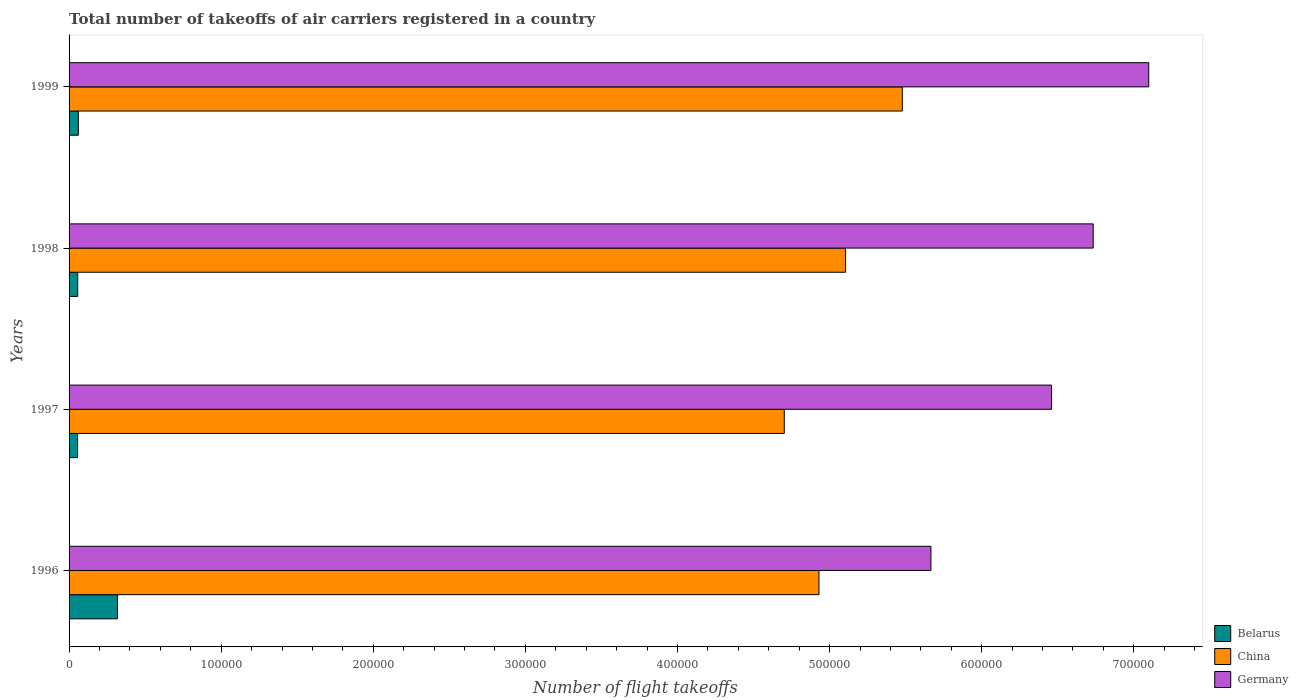Are the number of bars on each tick of the Y-axis equal?
Offer a terse response. Yes. How many bars are there on the 2nd tick from the top?
Ensure brevity in your answer.  3. What is the total number of flight takeoffs in Germany in 1999?
Ensure brevity in your answer.  7.10e+05. Across all years, what is the maximum total number of flight takeoffs in China?
Provide a succinct answer. 5.48e+05. Across all years, what is the minimum total number of flight takeoffs in China?
Provide a short and direct response. 4.70e+05. In which year was the total number of flight takeoffs in Belarus maximum?
Provide a succinct answer. 1996. What is the total total number of flight takeoffs in China in the graph?
Make the answer very short. 2.02e+06. What is the difference between the total number of flight takeoffs in Germany in 1997 and that in 1998?
Give a very brief answer. -2.74e+04. What is the difference between the total number of flight takeoffs in China in 1996 and the total number of flight takeoffs in Belarus in 1998?
Provide a short and direct response. 4.87e+05. What is the average total number of flight takeoffs in Belarus per year?
Ensure brevity in your answer.  1.23e+04. In the year 1998, what is the difference between the total number of flight takeoffs in China and total number of flight takeoffs in Germany?
Keep it short and to the point. -1.63e+05. In how many years, is the total number of flight takeoffs in Belarus greater than 680000 ?
Offer a terse response. 0. What is the ratio of the total number of flight takeoffs in Germany in 1996 to that in 1997?
Offer a terse response. 0.88. Is the total number of flight takeoffs in China in 1997 less than that in 1999?
Keep it short and to the point. Yes. Is the difference between the total number of flight takeoffs in China in 1996 and 1997 greater than the difference between the total number of flight takeoffs in Germany in 1996 and 1997?
Give a very brief answer. Yes. What is the difference between the highest and the second highest total number of flight takeoffs in Belarus?
Make the answer very short. 2.57e+04. What is the difference between the highest and the lowest total number of flight takeoffs in Germany?
Your answer should be very brief. 1.43e+05. Is the sum of the total number of flight takeoffs in Germany in 1996 and 1998 greater than the maximum total number of flight takeoffs in China across all years?
Provide a short and direct response. Yes. What does the 3rd bar from the top in 1998 represents?
Ensure brevity in your answer.  Belarus. What does the 2nd bar from the bottom in 1998 represents?
Ensure brevity in your answer.  China. Is it the case that in every year, the sum of the total number of flight takeoffs in Germany and total number of flight takeoffs in China is greater than the total number of flight takeoffs in Belarus?
Offer a terse response. Yes. How many bars are there?
Your answer should be very brief. 12. Are all the bars in the graph horizontal?
Offer a very short reply. Yes. Does the graph contain any zero values?
Make the answer very short. No. Does the graph contain grids?
Your answer should be compact. No. Where does the legend appear in the graph?
Provide a short and direct response. Bottom right. How are the legend labels stacked?
Give a very brief answer. Vertical. What is the title of the graph?
Your answer should be very brief. Total number of takeoffs of air carriers registered in a country. What is the label or title of the X-axis?
Provide a succinct answer. Number of flight takeoffs. What is the Number of flight takeoffs in Belarus in 1996?
Ensure brevity in your answer.  3.18e+04. What is the Number of flight takeoffs in China in 1996?
Your answer should be very brief. 4.93e+05. What is the Number of flight takeoffs in Germany in 1996?
Your response must be concise. 5.67e+05. What is the Number of flight takeoffs of Belarus in 1997?
Your answer should be compact. 5600. What is the Number of flight takeoffs of China in 1997?
Make the answer very short. 4.70e+05. What is the Number of flight takeoffs in Germany in 1997?
Provide a short and direct response. 6.46e+05. What is the Number of flight takeoffs of Belarus in 1998?
Offer a terse response. 5700. What is the Number of flight takeoffs in China in 1998?
Give a very brief answer. 5.10e+05. What is the Number of flight takeoffs of Germany in 1998?
Your answer should be compact. 6.73e+05. What is the Number of flight takeoffs of Belarus in 1999?
Offer a terse response. 6100. What is the Number of flight takeoffs of China in 1999?
Offer a very short reply. 5.48e+05. What is the Number of flight takeoffs of Germany in 1999?
Give a very brief answer. 7.10e+05. Across all years, what is the maximum Number of flight takeoffs in Belarus?
Your answer should be compact. 3.18e+04. Across all years, what is the maximum Number of flight takeoffs of China?
Your answer should be very brief. 5.48e+05. Across all years, what is the maximum Number of flight takeoffs of Germany?
Provide a short and direct response. 7.10e+05. Across all years, what is the minimum Number of flight takeoffs in Belarus?
Provide a succinct answer. 5600. Across all years, what is the minimum Number of flight takeoffs of China?
Your response must be concise. 4.70e+05. Across all years, what is the minimum Number of flight takeoffs in Germany?
Give a very brief answer. 5.67e+05. What is the total Number of flight takeoffs of Belarus in the graph?
Offer a terse response. 4.92e+04. What is the total Number of flight takeoffs of China in the graph?
Your answer should be compact. 2.02e+06. What is the total Number of flight takeoffs of Germany in the graph?
Make the answer very short. 2.60e+06. What is the difference between the Number of flight takeoffs of Belarus in 1996 and that in 1997?
Your answer should be compact. 2.62e+04. What is the difference between the Number of flight takeoffs in China in 1996 and that in 1997?
Offer a terse response. 2.28e+04. What is the difference between the Number of flight takeoffs of Germany in 1996 and that in 1997?
Your answer should be very brief. -7.93e+04. What is the difference between the Number of flight takeoffs in Belarus in 1996 and that in 1998?
Provide a succinct answer. 2.61e+04. What is the difference between the Number of flight takeoffs of China in 1996 and that in 1998?
Offer a very short reply. -1.75e+04. What is the difference between the Number of flight takeoffs in Germany in 1996 and that in 1998?
Your answer should be compact. -1.07e+05. What is the difference between the Number of flight takeoffs of Belarus in 1996 and that in 1999?
Keep it short and to the point. 2.57e+04. What is the difference between the Number of flight takeoffs in China in 1996 and that in 1999?
Offer a very short reply. -5.48e+04. What is the difference between the Number of flight takeoffs of Germany in 1996 and that in 1999?
Provide a short and direct response. -1.43e+05. What is the difference between the Number of flight takeoffs in Belarus in 1997 and that in 1998?
Make the answer very short. -100. What is the difference between the Number of flight takeoffs of China in 1997 and that in 1998?
Ensure brevity in your answer.  -4.03e+04. What is the difference between the Number of flight takeoffs of Germany in 1997 and that in 1998?
Give a very brief answer. -2.74e+04. What is the difference between the Number of flight takeoffs in Belarus in 1997 and that in 1999?
Your answer should be very brief. -500. What is the difference between the Number of flight takeoffs in China in 1997 and that in 1999?
Make the answer very short. -7.76e+04. What is the difference between the Number of flight takeoffs of Germany in 1997 and that in 1999?
Your answer should be compact. -6.39e+04. What is the difference between the Number of flight takeoffs of Belarus in 1998 and that in 1999?
Your answer should be very brief. -400. What is the difference between the Number of flight takeoffs in China in 1998 and that in 1999?
Offer a very short reply. -3.73e+04. What is the difference between the Number of flight takeoffs of Germany in 1998 and that in 1999?
Offer a very short reply. -3.65e+04. What is the difference between the Number of flight takeoffs in Belarus in 1996 and the Number of flight takeoffs in China in 1997?
Provide a succinct answer. -4.38e+05. What is the difference between the Number of flight takeoffs of Belarus in 1996 and the Number of flight takeoffs of Germany in 1997?
Your answer should be very brief. -6.14e+05. What is the difference between the Number of flight takeoffs in China in 1996 and the Number of flight takeoffs in Germany in 1997?
Your answer should be very brief. -1.53e+05. What is the difference between the Number of flight takeoffs in Belarus in 1996 and the Number of flight takeoffs in China in 1998?
Offer a terse response. -4.79e+05. What is the difference between the Number of flight takeoffs of Belarus in 1996 and the Number of flight takeoffs of Germany in 1998?
Give a very brief answer. -6.42e+05. What is the difference between the Number of flight takeoffs in China in 1996 and the Number of flight takeoffs in Germany in 1998?
Provide a short and direct response. -1.80e+05. What is the difference between the Number of flight takeoffs in Belarus in 1996 and the Number of flight takeoffs in China in 1999?
Offer a terse response. -5.16e+05. What is the difference between the Number of flight takeoffs in Belarus in 1996 and the Number of flight takeoffs in Germany in 1999?
Your answer should be very brief. -6.78e+05. What is the difference between the Number of flight takeoffs of China in 1996 and the Number of flight takeoffs of Germany in 1999?
Ensure brevity in your answer.  -2.17e+05. What is the difference between the Number of flight takeoffs of Belarus in 1997 and the Number of flight takeoffs of China in 1998?
Keep it short and to the point. -5.05e+05. What is the difference between the Number of flight takeoffs in Belarus in 1997 and the Number of flight takeoffs in Germany in 1998?
Ensure brevity in your answer.  -6.68e+05. What is the difference between the Number of flight takeoffs of China in 1997 and the Number of flight takeoffs of Germany in 1998?
Provide a succinct answer. -2.03e+05. What is the difference between the Number of flight takeoffs of Belarus in 1997 and the Number of flight takeoffs of China in 1999?
Offer a very short reply. -5.42e+05. What is the difference between the Number of flight takeoffs of Belarus in 1997 and the Number of flight takeoffs of Germany in 1999?
Give a very brief answer. -7.04e+05. What is the difference between the Number of flight takeoffs of China in 1997 and the Number of flight takeoffs of Germany in 1999?
Provide a succinct answer. -2.40e+05. What is the difference between the Number of flight takeoffs of Belarus in 1998 and the Number of flight takeoffs of China in 1999?
Offer a very short reply. -5.42e+05. What is the difference between the Number of flight takeoffs of Belarus in 1998 and the Number of flight takeoffs of Germany in 1999?
Ensure brevity in your answer.  -7.04e+05. What is the difference between the Number of flight takeoffs in China in 1998 and the Number of flight takeoffs in Germany in 1999?
Provide a short and direct response. -1.99e+05. What is the average Number of flight takeoffs in Belarus per year?
Provide a succinct answer. 1.23e+04. What is the average Number of flight takeoffs in China per year?
Offer a terse response. 5.05e+05. What is the average Number of flight takeoffs in Germany per year?
Ensure brevity in your answer.  6.49e+05. In the year 1996, what is the difference between the Number of flight takeoffs in Belarus and Number of flight takeoffs in China?
Your response must be concise. -4.61e+05. In the year 1996, what is the difference between the Number of flight takeoffs of Belarus and Number of flight takeoffs of Germany?
Ensure brevity in your answer.  -5.35e+05. In the year 1996, what is the difference between the Number of flight takeoffs in China and Number of flight takeoffs in Germany?
Your answer should be compact. -7.36e+04. In the year 1997, what is the difference between the Number of flight takeoffs in Belarus and Number of flight takeoffs in China?
Provide a short and direct response. -4.65e+05. In the year 1997, what is the difference between the Number of flight takeoffs of Belarus and Number of flight takeoffs of Germany?
Give a very brief answer. -6.40e+05. In the year 1997, what is the difference between the Number of flight takeoffs of China and Number of flight takeoffs of Germany?
Your answer should be very brief. -1.76e+05. In the year 1998, what is the difference between the Number of flight takeoffs in Belarus and Number of flight takeoffs in China?
Offer a very short reply. -5.05e+05. In the year 1998, what is the difference between the Number of flight takeoffs in Belarus and Number of flight takeoffs in Germany?
Your response must be concise. -6.68e+05. In the year 1998, what is the difference between the Number of flight takeoffs of China and Number of flight takeoffs of Germany?
Provide a succinct answer. -1.63e+05. In the year 1999, what is the difference between the Number of flight takeoffs in Belarus and Number of flight takeoffs in China?
Offer a very short reply. -5.42e+05. In the year 1999, what is the difference between the Number of flight takeoffs in Belarus and Number of flight takeoffs in Germany?
Your response must be concise. -7.04e+05. In the year 1999, what is the difference between the Number of flight takeoffs in China and Number of flight takeoffs in Germany?
Offer a very short reply. -1.62e+05. What is the ratio of the Number of flight takeoffs in Belarus in 1996 to that in 1997?
Your answer should be compact. 5.68. What is the ratio of the Number of flight takeoffs of China in 1996 to that in 1997?
Your response must be concise. 1.05. What is the ratio of the Number of flight takeoffs in Germany in 1996 to that in 1997?
Offer a very short reply. 0.88. What is the ratio of the Number of flight takeoffs of Belarus in 1996 to that in 1998?
Give a very brief answer. 5.58. What is the ratio of the Number of flight takeoffs in China in 1996 to that in 1998?
Offer a terse response. 0.97. What is the ratio of the Number of flight takeoffs in Germany in 1996 to that in 1998?
Ensure brevity in your answer.  0.84. What is the ratio of the Number of flight takeoffs of Belarus in 1996 to that in 1999?
Ensure brevity in your answer.  5.21. What is the ratio of the Number of flight takeoffs of China in 1996 to that in 1999?
Provide a succinct answer. 0.9. What is the ratio of the Number of flight takeoffs of Germany in 1996 to that in 1999?
Offer a very short reply. 0.8. What is the ratio of the Number of flight takeoffs of Belarus in 1997 to that in 1998?
Provide a succinct answer. 0.98. What is the ratio of the Number of flight takeoffs in China in 1997 to that in 1998?
Your answer should be very brief. 0.92. What is the ratio of the Number of flight takeoffs in Germany in 1997 to that in 1998?
Provide a short and direct response. 0.96. What is the ratio of the Number of flight takeoffs in Belarus in 1997 to that in 1999?
Ensure brevity in your answer.  0.92. What is the ratio of the Number of flight takeoffs in China in 1997 to that in 1999?
Give a very brief answer. 0.86. What is the ratio of the Number of flight takeoffs in Germany in 1997 to that in 1999?
Your answer should be very brief. 0.91. What is the ratio of the Number of flight takeoffs in Belarus in 1998 to that in 1999?
Offer a very short reply. 0.93. What is the ratio of the Number of flight takeoffs in China in 1998 to that in 1999?
Offer a terse response. 0.93. What is the ratio of the Number of flight takeoffs in Germany in 1998 to that in 1999?
Make the answer very short. 0.95. What is the difference between the highest and the second highest Number of flight takeoffs in Belarus?
Provide a short and direct response. 2.57e+04. What is the difference between the highest and the second highest Number of flight takeoffs of China?
Provide a succinct answer. 3.73e+04. What is the difference between the highest and the second highest Number of flight takeoffs in Germany?
Make the answer very short. 3.65e+04. What is the difference between the highest and the lowest Number of flight takeoffs in Belarus?
Your response must be concise. 2.62e+04. What is the difference between the highest and the lowest Number of flight takeoffs of China?
Offer a very short reply. 7.76e+04. What is the difference between the highest and the lowest Number of flight takeoffs of Germany?
Ensure brevity in your answer.  1.43e+05. 